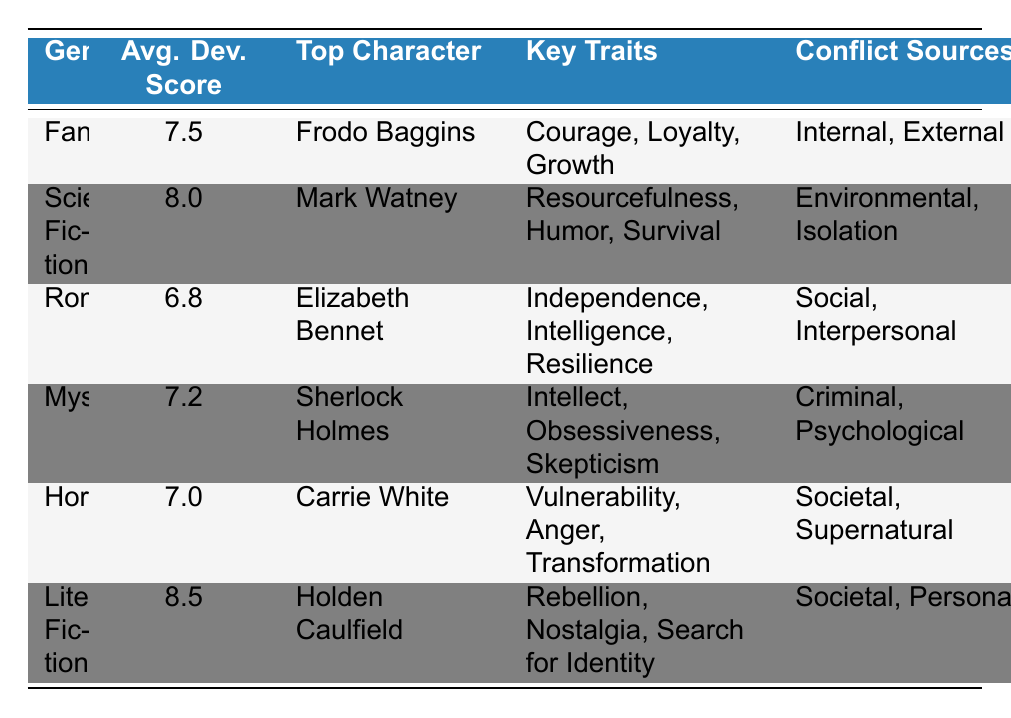What is the average development score for the Romance genre? The table shows that the average development score for the Romance genre is stated directly under the "Avg. Dev. Score" column for Romance. Looking at that row, it is 6.8.
Answer: 6.8 Which character from Literary Fiction has the highest average development score, and what is that score? The table indicates that Holden Caulfield is the top character in Literary Fiction. The average development score for this genre is listed in the corresponding row, which is 8.5.
Answer: Holden Caulfield, 8.5 Is the average development score for Fantasy higher than that of Horror? The average development score for Fantasy is 7.5, and for Horror, it is 7.0. Since 7.5 > 7.0, the statement is true.
Answer: Yes What are the key traits of the character from the Mystery genre? To find this, we look at the row for the Mystery genre in the table. The key traits listed for Sherlock Holmes, the top character in Mystery, are Intellect, Obsessiveness, and Skepticism.
Answer: Intellect, Obsessiveness, Skepticism What is the total average development score of Fantasy, Romance, and Mystery genres combined? First, we sum the average development scores from the specified genres: Fantasy (7.5), Romance (6.8), and Mystery (7.2). The total is 7.5 + 6.8 + 7.2 = 21.5. To find the average score, we then divide by the number of genres (3): 21.5 / 3 = 7.16667, which can be rounded to 7.17.
Answer: 7.17 Is there a character from the Science Fiction genre that exhibits traits of Humor? Yes, the table shows that Mark Watney, the character from Science Fiction, possesses resourcefulness, humor, and survival as key traits. Therefore, the statement is true.
Answer: Yes Which genre has the lowest average development score and what is that score? By comparing the average development scores for all genres listed, Romance has the lowest score of 6.8.
Answer: Romance, 6.8 What sources of conflict are identified for the character in Horror? Referring to the Horror row in the table, the conflict sources for Carrie White are listed as Societal and Supernatural.
Answer: Societal, Supernatural 